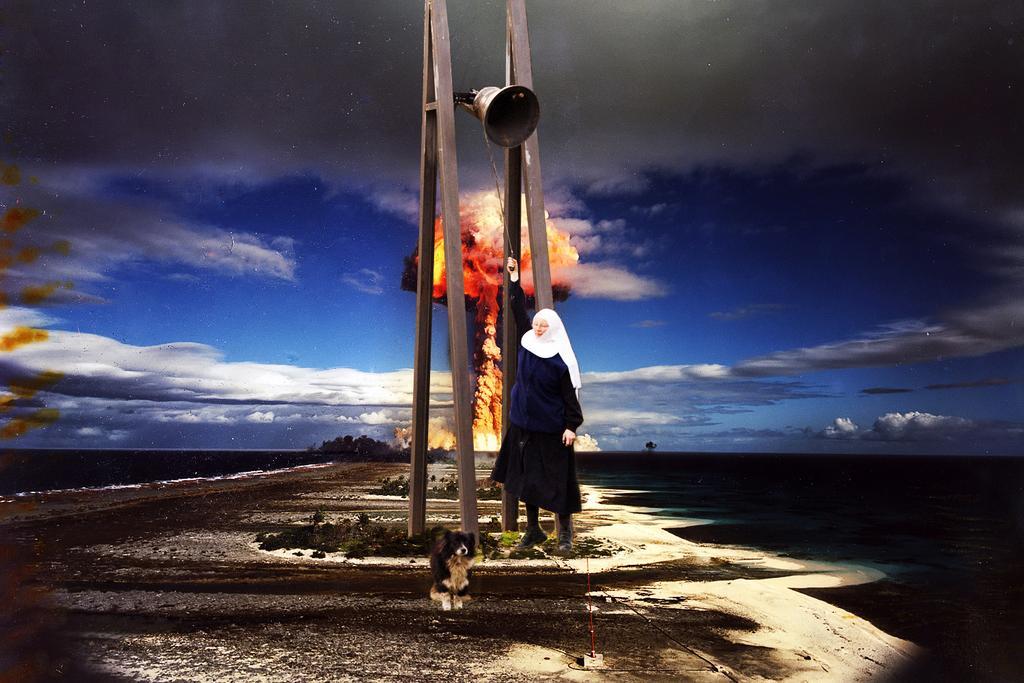Can you describe this image briefly? In the image we can see a person standing, wearing clothes and we can even see a dog. Here we can see footpath, flame, grass and the cloudy sky. 